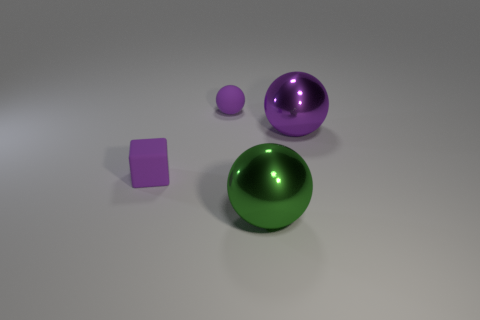How many things are large balls that are behind the big green object or small things?
Provide a short and direct response. 3. The rubber sphere has what size?
Offer a very short reply. Small. There is a big purple object in front of the small object behind the tiny matte block; what is its material?
Make the answer very short. Metal. There is a purple matte thing that is in front of the purple matte sphere; is it the same size as the green object?
Provide a short and direct response. No. Is there a rubber thing that has the same color as the matte ball?
Your answer should be very brief. Yes. How many objects are either purple spheres in front of the rubber sphere or large balls that are on the right side of the big green sphere?
Ensure brevity in your answer.  1. Does the small rubber block have the same color as the matte sphere?
Offer a very short reply. Yes. What material is the small sphere that is the same color as the matte cube?
Your answer should be compact. Rubber. Is the number of big purple things behind the small purple ball less than the number of big green shiny spheres that are right of the big green shiny sphere?
Provide a short and direct response. No. Is the large green object made of the same material as the purple block?
Your answer should be compact. No. 